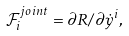<formula> <loc_0><loc_0><loc_500><loc_500>\mathcal { F } _ { i } ^ { j o i n t } = \partial R / \partial \dot { y } ^ { i } ,</formula> 